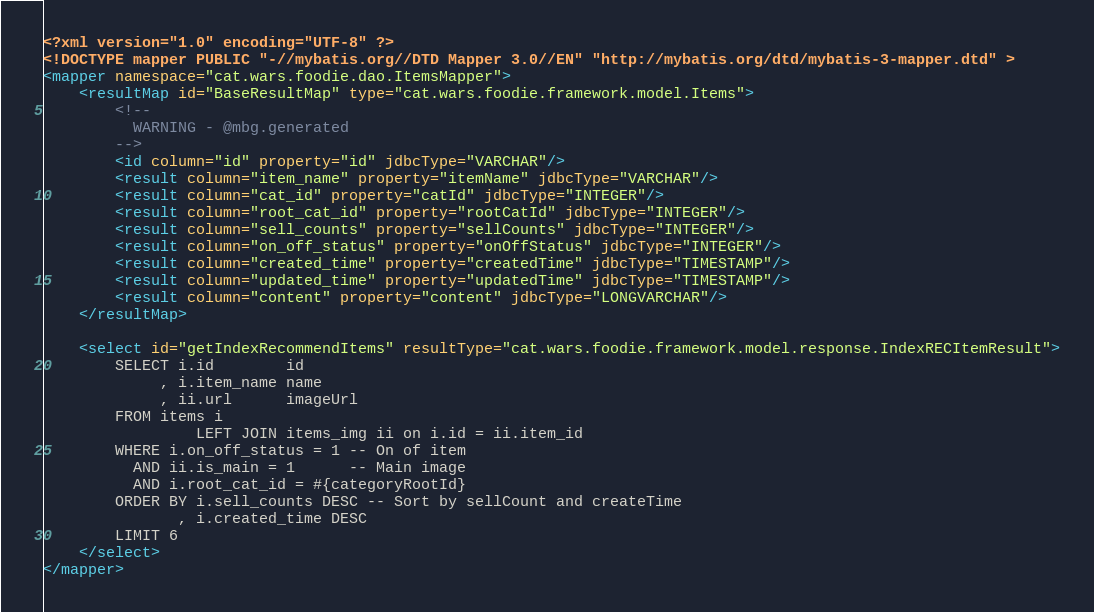Convert code to text. <code><loc_0><loc_0><loc_500><loc_500><_XML_><?xml version="1.0" encoding="UTF-8" ?>
<!DOCTYPE mapper PUBLIC "-//mybatis.org//DTD Mapper 3.0//EN" "http://mybatis.org/dtd/mybatis-3-mapper.dtd" >
<mapper namespace="cat.wars.foodie.dao.ItemsMapper">
    <resultMap id="BaseResultMap" type="cat.wars.foodie.framework.model.Items">
        <!--
          WARNING - @mbg.generated
        -->
        <id column="id" property="id" jdbcType="VARCHAR"/>
        <result column="item_name" property="itemName" jdbcType="VARCHAR"/>
        <result column="cat_id" property="catId" jdbcType="INTEGER"/>
        <result column="root_cat_id" property="rootCatId" jdbcType="INTEGER"/>
        <result column="sell_counts" property="sellCounts" jdbcType="INTEGER"/>
        <result column="on_off_status" property="onOffStatus" jdbcType="INTEGER"/>
        <result column="created_time" property="createdTime" jdbcType="TIMESTAMP"/>
        <result column="updated_time" property="updatedTime" jdbcType="TIMESTAMP"/>
        <result column="content" property="content" jdbcType="LONGVARCHAR"/>
    </resultMap>

    <select id="getIndexRecommendItems" resultType="cat.wars.foodie.framework.model.response.IndexRECItemResult">
        SELECT i.id        id
             , i.item_name name
             , ii.url      imageUrl
        FROM items i
                 LEFT JOIN items_img ii on i.id = ii.item_id
        WHERE i.on_off_status = 1 -- On of item
          AND ii.is_main = 1      -- Main image
          AND i.root_cat_id = #{categoryRootId}
        ORDER BY i.sell_counts DESC -- Sort by sellCount and createTime
               , i.created_time DESC
        LIMIT 6
    </select>
</mapper></code> 